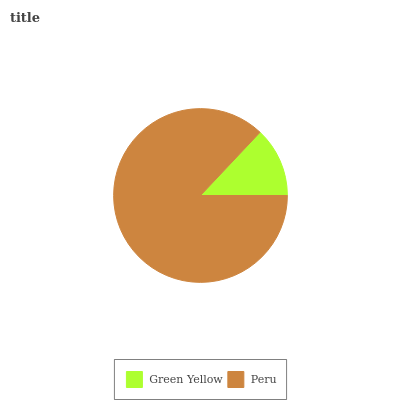Is Green Yellow the minimum?
Answer yes or no. Yes. Is Peru the maximum?
Answer yes or no. Yes. Is Peru the minimum?
Answer yes or no. No. Is Peru greater than Green Yellow?
Answer yes or no. Yes. Is Green Yellow less than Peru?
Answer yes or no. Yes. Is Green Yellow greater than Peru?
Answer yes or no. No. Is Peru less than Green Yellow?
Answer yes or no. No. Is Peru the high median?
Answer yes or no. Yes. Is Green Yellow the low median?
Answer yes or no. Yes. Is Green Yellow the high median?
Answer yes or no. No. Is Peru the low median?
Answer yes or no. No. 